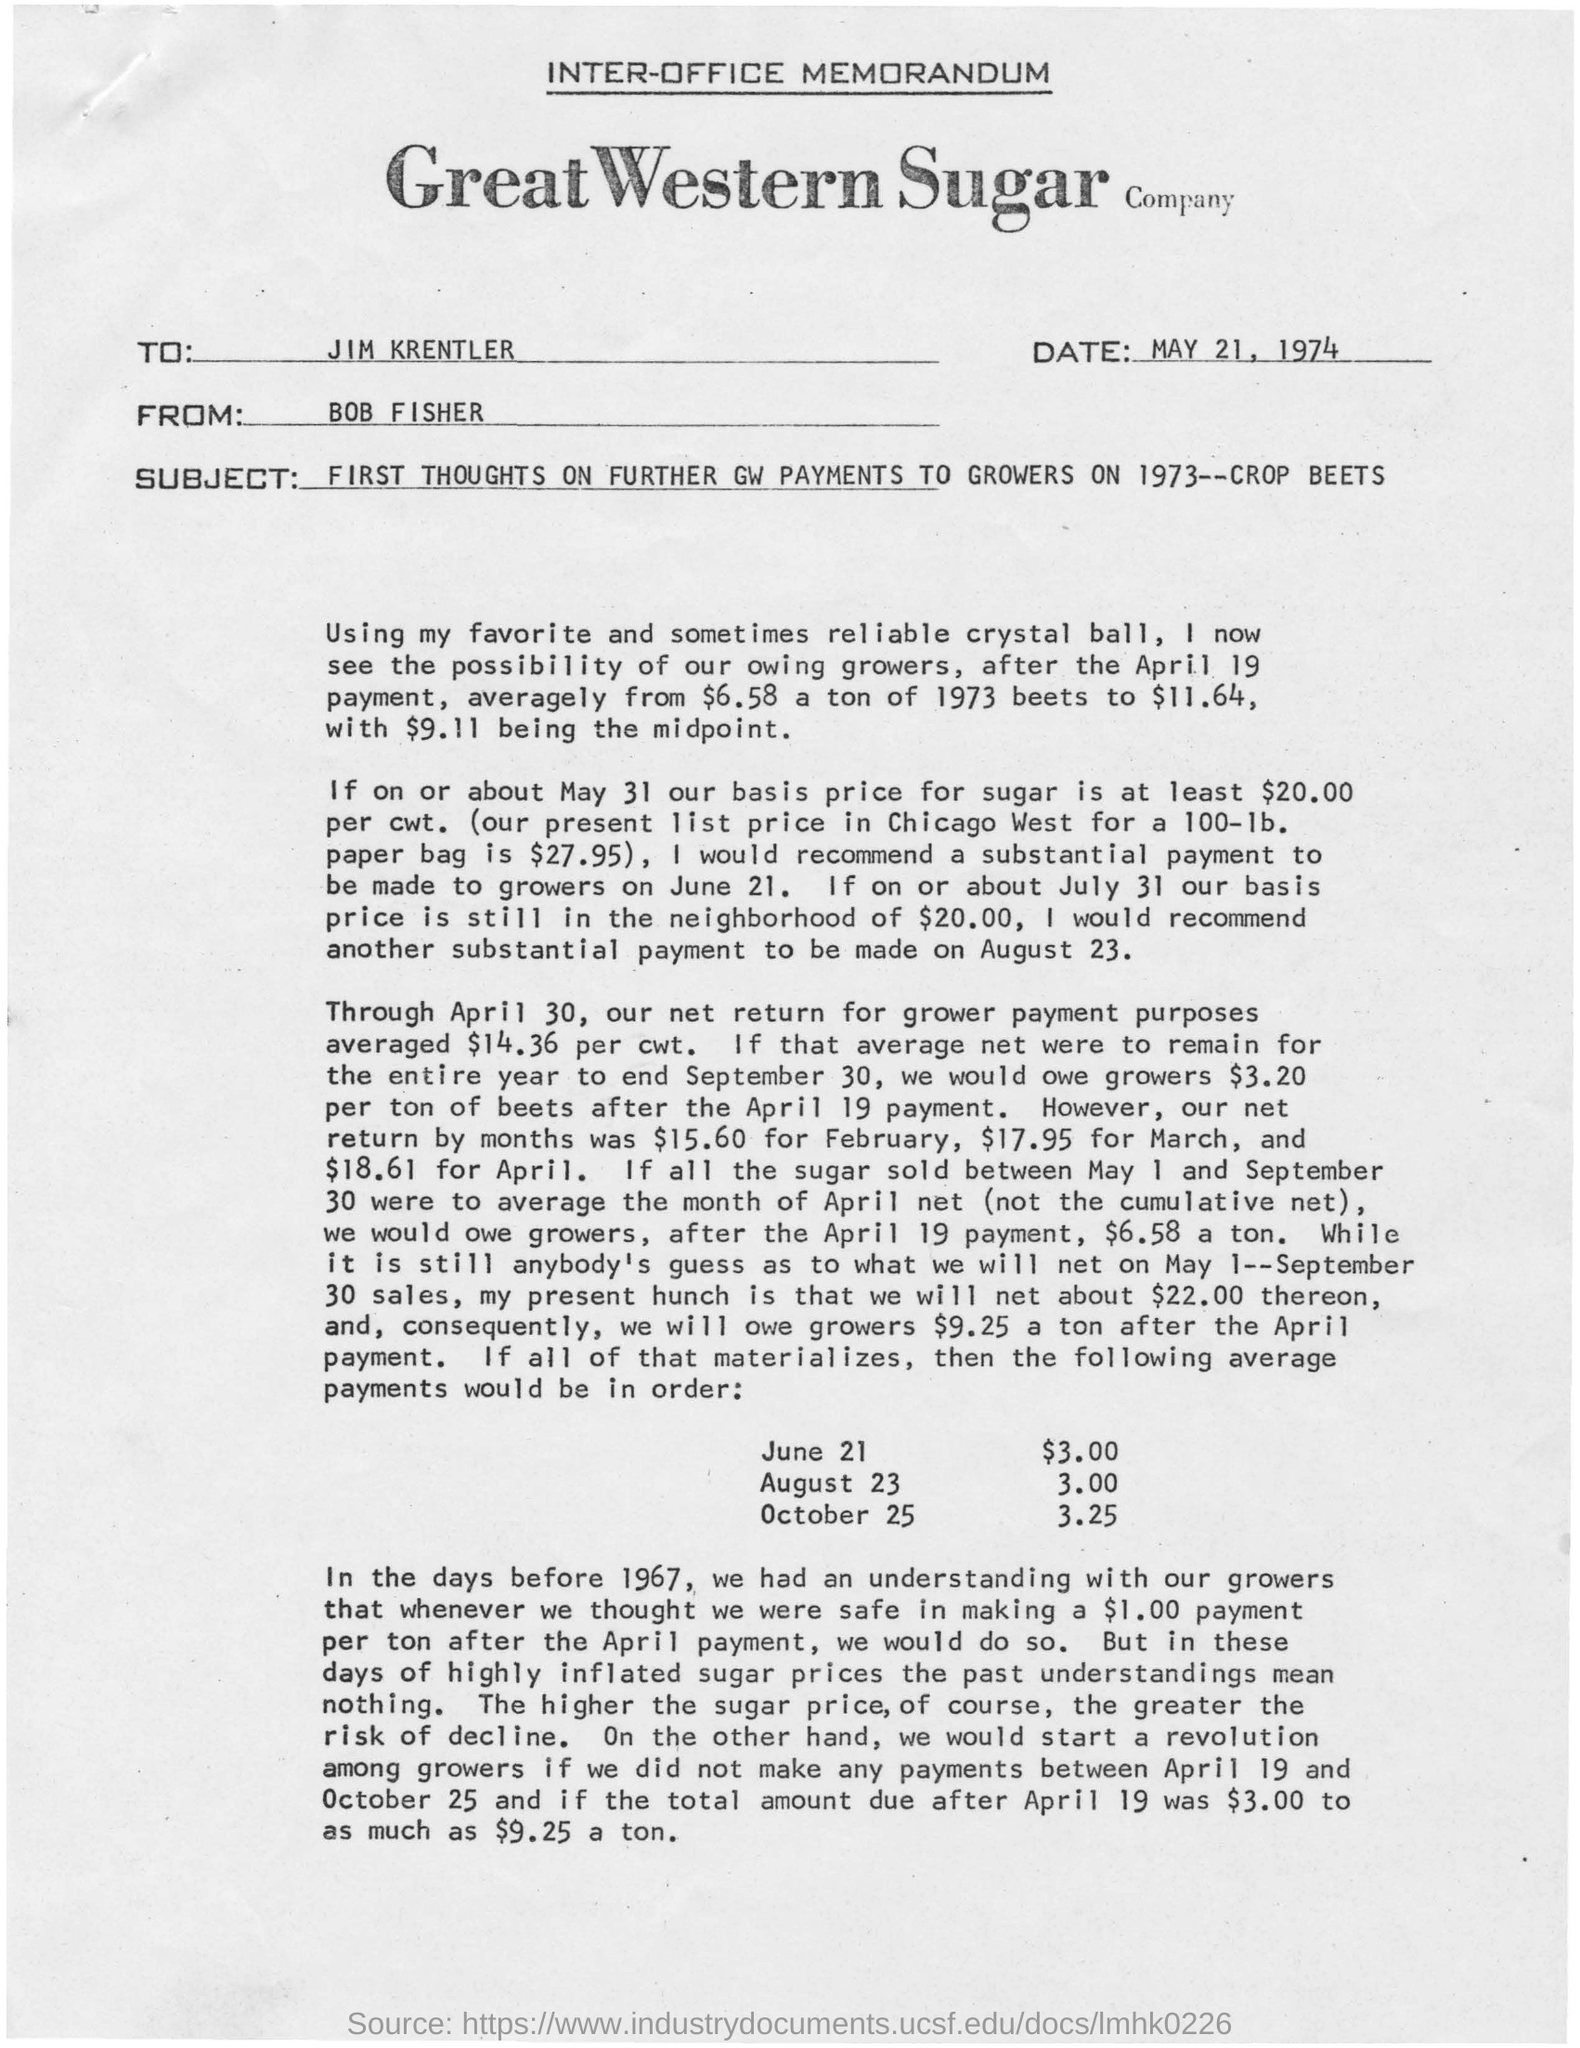Give some essential details in this illustration. The document mentions a date of MAY 21, 1974. The subject line of the document is 'First Thoughts on Further GW Payments to Growers on 1973--Crop Beets.' The company named Great Western Sugar..., Bob Fisher sent this message. The recipient of this message is Jim Krentler. 